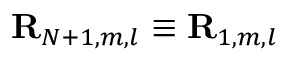<formula> <loc_0><loc_0><loc_500><loc_500>{ R } _ { N + 1 , m , l } \equiv R _ { 1 , m , l }</formula> 